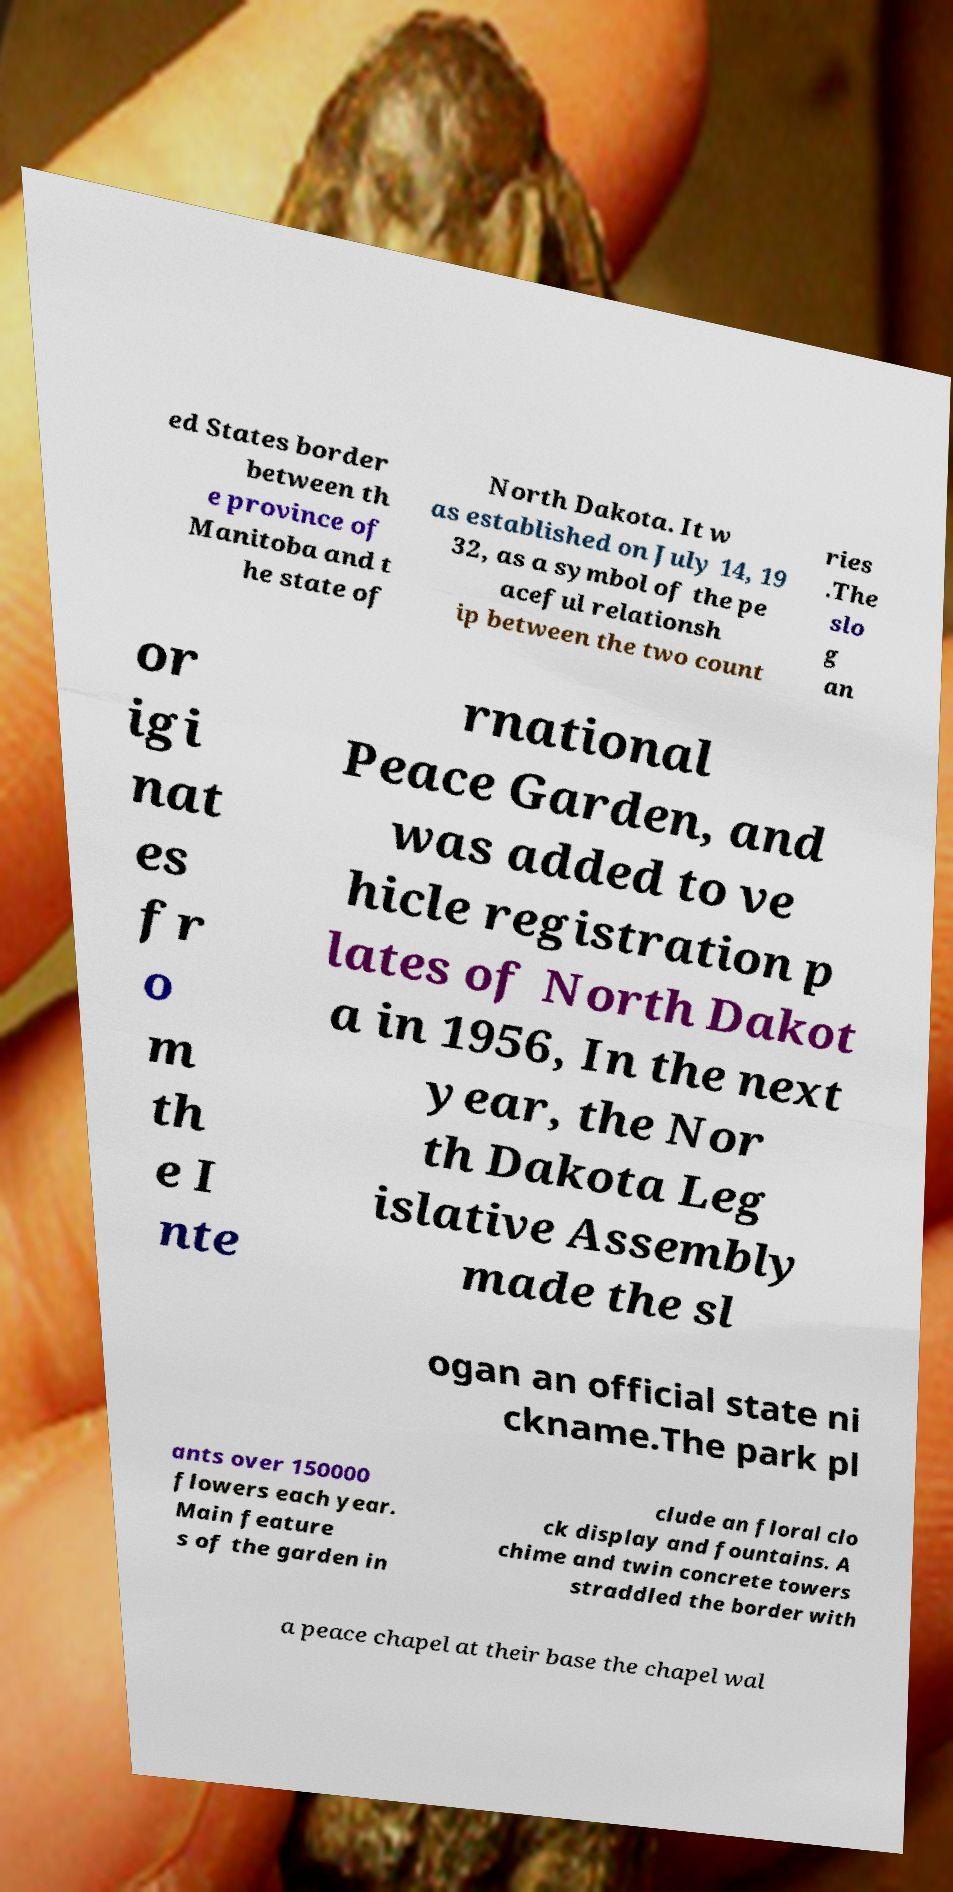I need the written content from this picture converted into text. Can you do that? ed States border between th e province of Manitoba and t he state of North Dakota. It w as established on July 14, 19 32, as a symbol of the pe aceful relationsh ip between the two count ries .The slo g an or igi nat es fr o m th e I nte rnational Peace Garden, and was added to ve hicle registration p lates of North Dakot a in 1956, In the next year, the Nor th Dakota Leg islative Assembly made the sl ogan an official state ni ckname.The park pl ants over 150000 flowers each year. Main feature s of the garden in clude an floral clo ck display and fountains. A chime and twin concrete towers straddled the border with a peace chapel at their base the chapel wal 